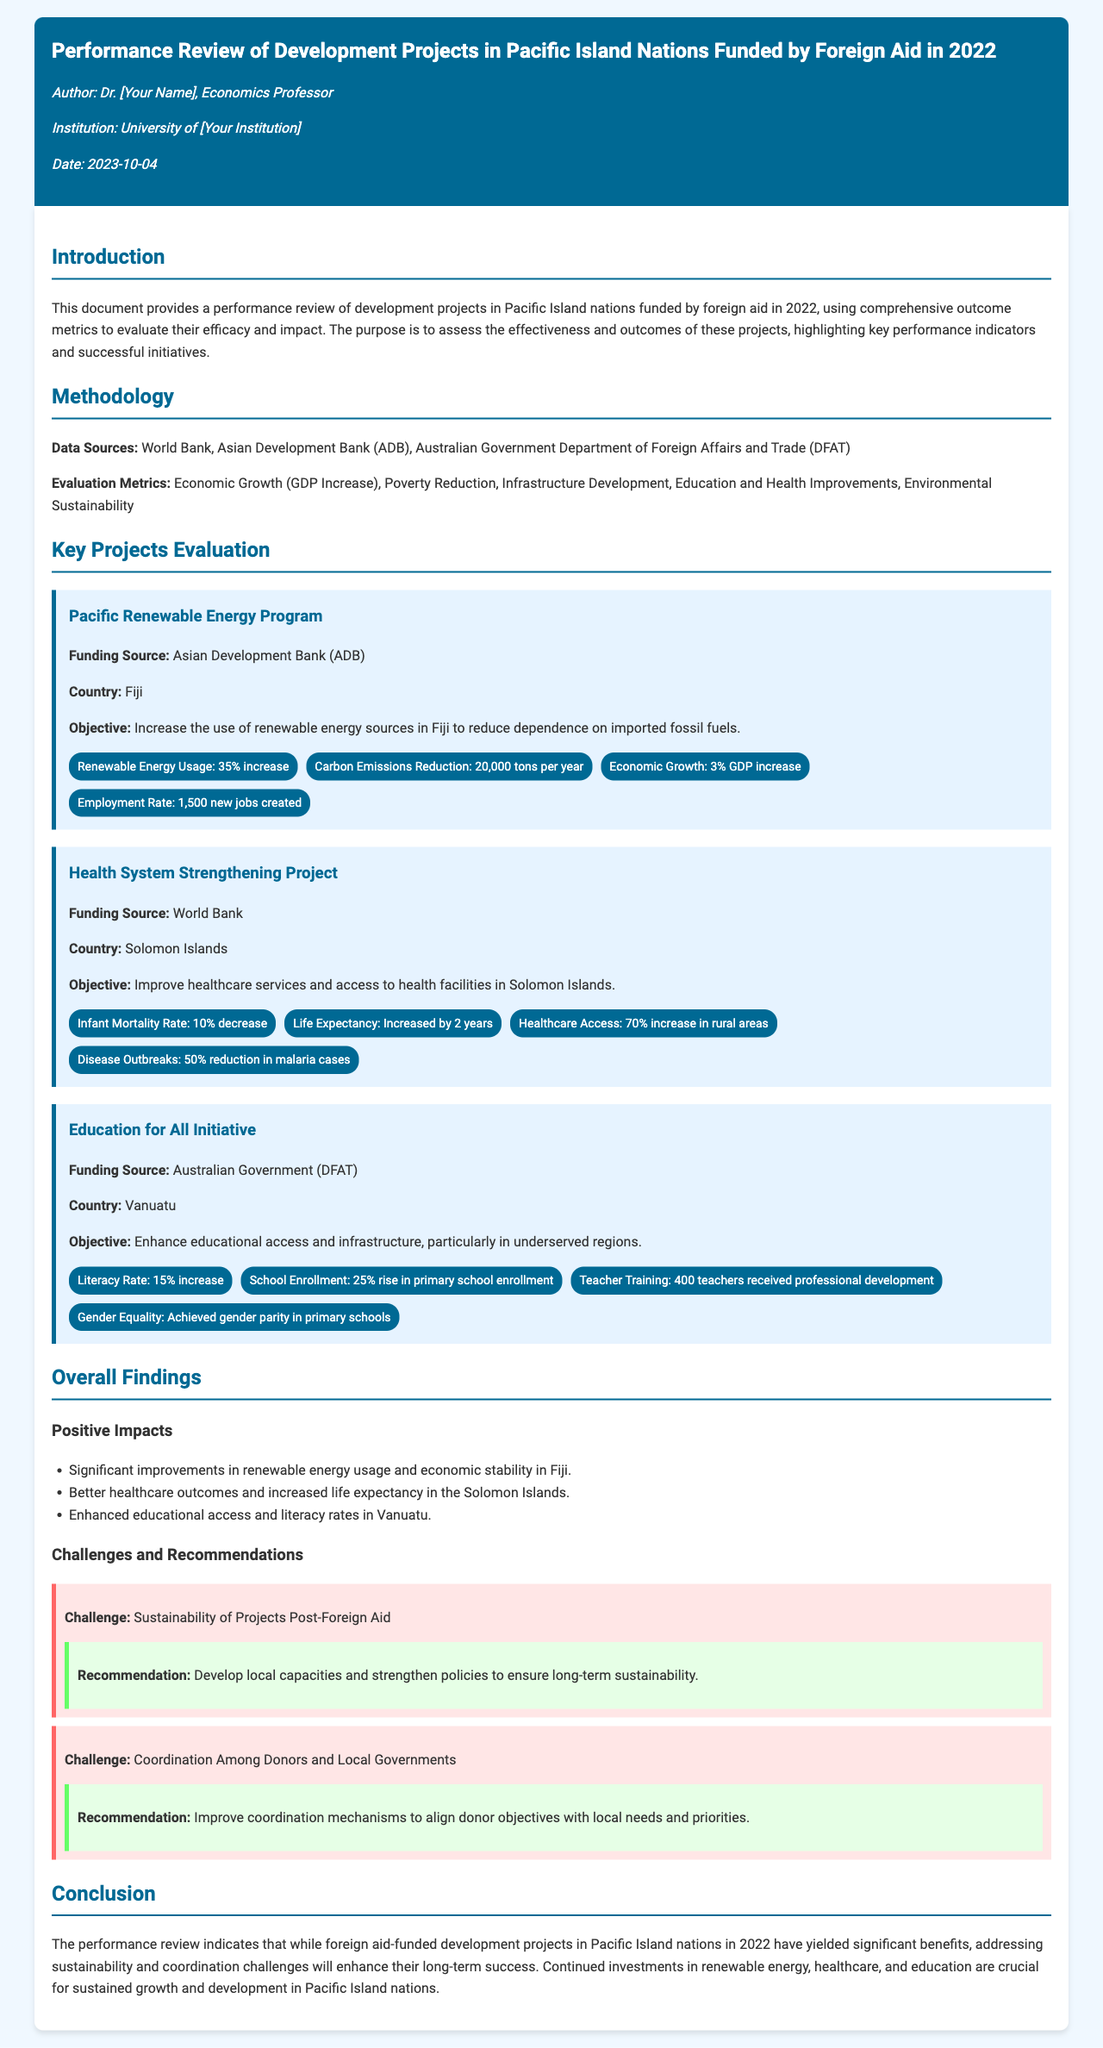What is the title of the document? The title is prominently displayed in the header section of the document.
Answer: Performance Review of Development Projects in Pacific Island Nations Funded by Foreign Aid in 2022 Who is the author of the document? The author's name is mentioned in the author info section of the document.
Answer: Dr. [Your Name] What was the funding source for the Pacific Renewable Energy Program? The funding source for this project is specified within the project description.
Answer: Asian Development Bank (ADB) What percentage increase in renewable energy usage was achieved in Fiji? The specific percentage increase is stated in the metrics section of the project discussion.
Answer: 35% increase Which country benefited from the Health System Strengthening Project? The document clearly identifies the country involved in this project.
Answer: Solomon Islands What significant reduction in infant mortality rate was noted in the Health System Strengthening Project? The document states the exact measurement of this reduction in the metrics section.
Answer: 10% decrease What was the primary objective of the Education for All Initiative? The objective is outlined in the project description of the initiative.
Answer: Enhance educational access and infrastructure, particularly in underserved regions What is a noted challenge related to the sustainability of projects post-foreign aid? The challenges are listed in the challenges section of the document.
Answer: Sustainability of Projects Post-Foreign Aid What recommendation is made to improve donor coordination with local governments? The recommendation is provided following the discussion about coordination challenges.
Answer: Improve coordination mechanisms to align donor objectives with local needs and priorities 